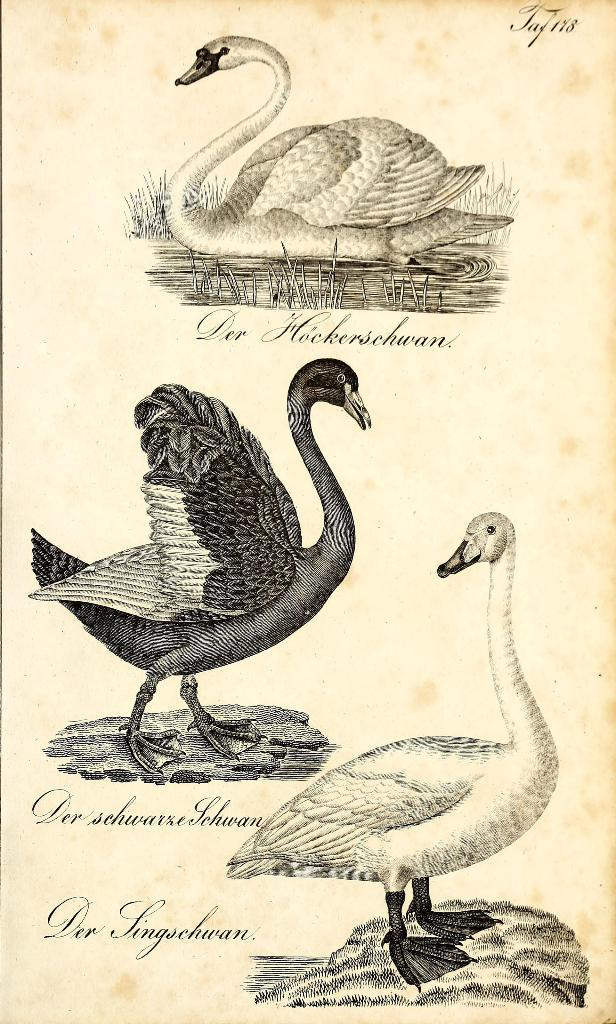What is present on the paper in the image? The paper contains drawings of swans and texts. Can you describe the drawings on the paper? The drawings on the paper depict swans. What else can be found on the paper besides the drawings? There are texts on the paper. What type of curtain is hanging in front of the swans in the image? There is no curtain present in the image; it only features a paper with drawings of swans and texts. 